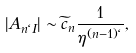Convert formula to latex. <formula><loc_0><loc_0><loc_500><loc_500>| A _ { n \ell I } | \sim \widetilde { c } _ { n } \frac { 1 } { \eta ^ { ( n - 1 ) \ell } } ,</formula> 